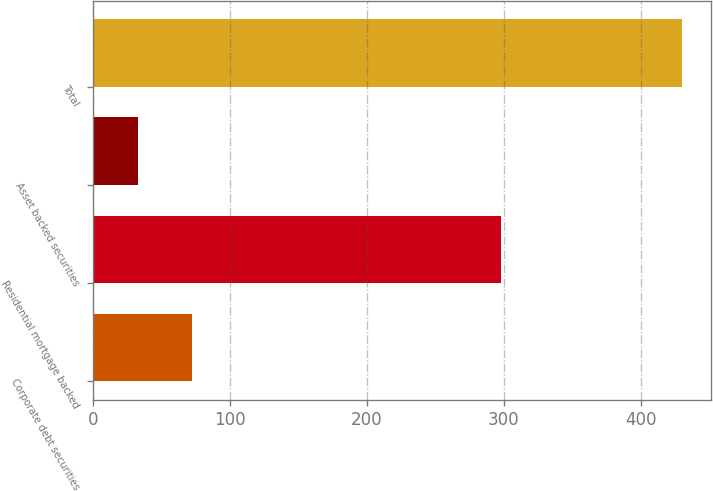Convert chart. <chart><loc_0><loc_0><loc_500><loc_500><bar_chart><fcel>Corporate debt securities<fcel>Residential mortgage backed<fcel>Asset backed securities<fcel>Total<nl><fcel>72.7<fcel>298<fcel>33<fcel>430<nl></chart> 